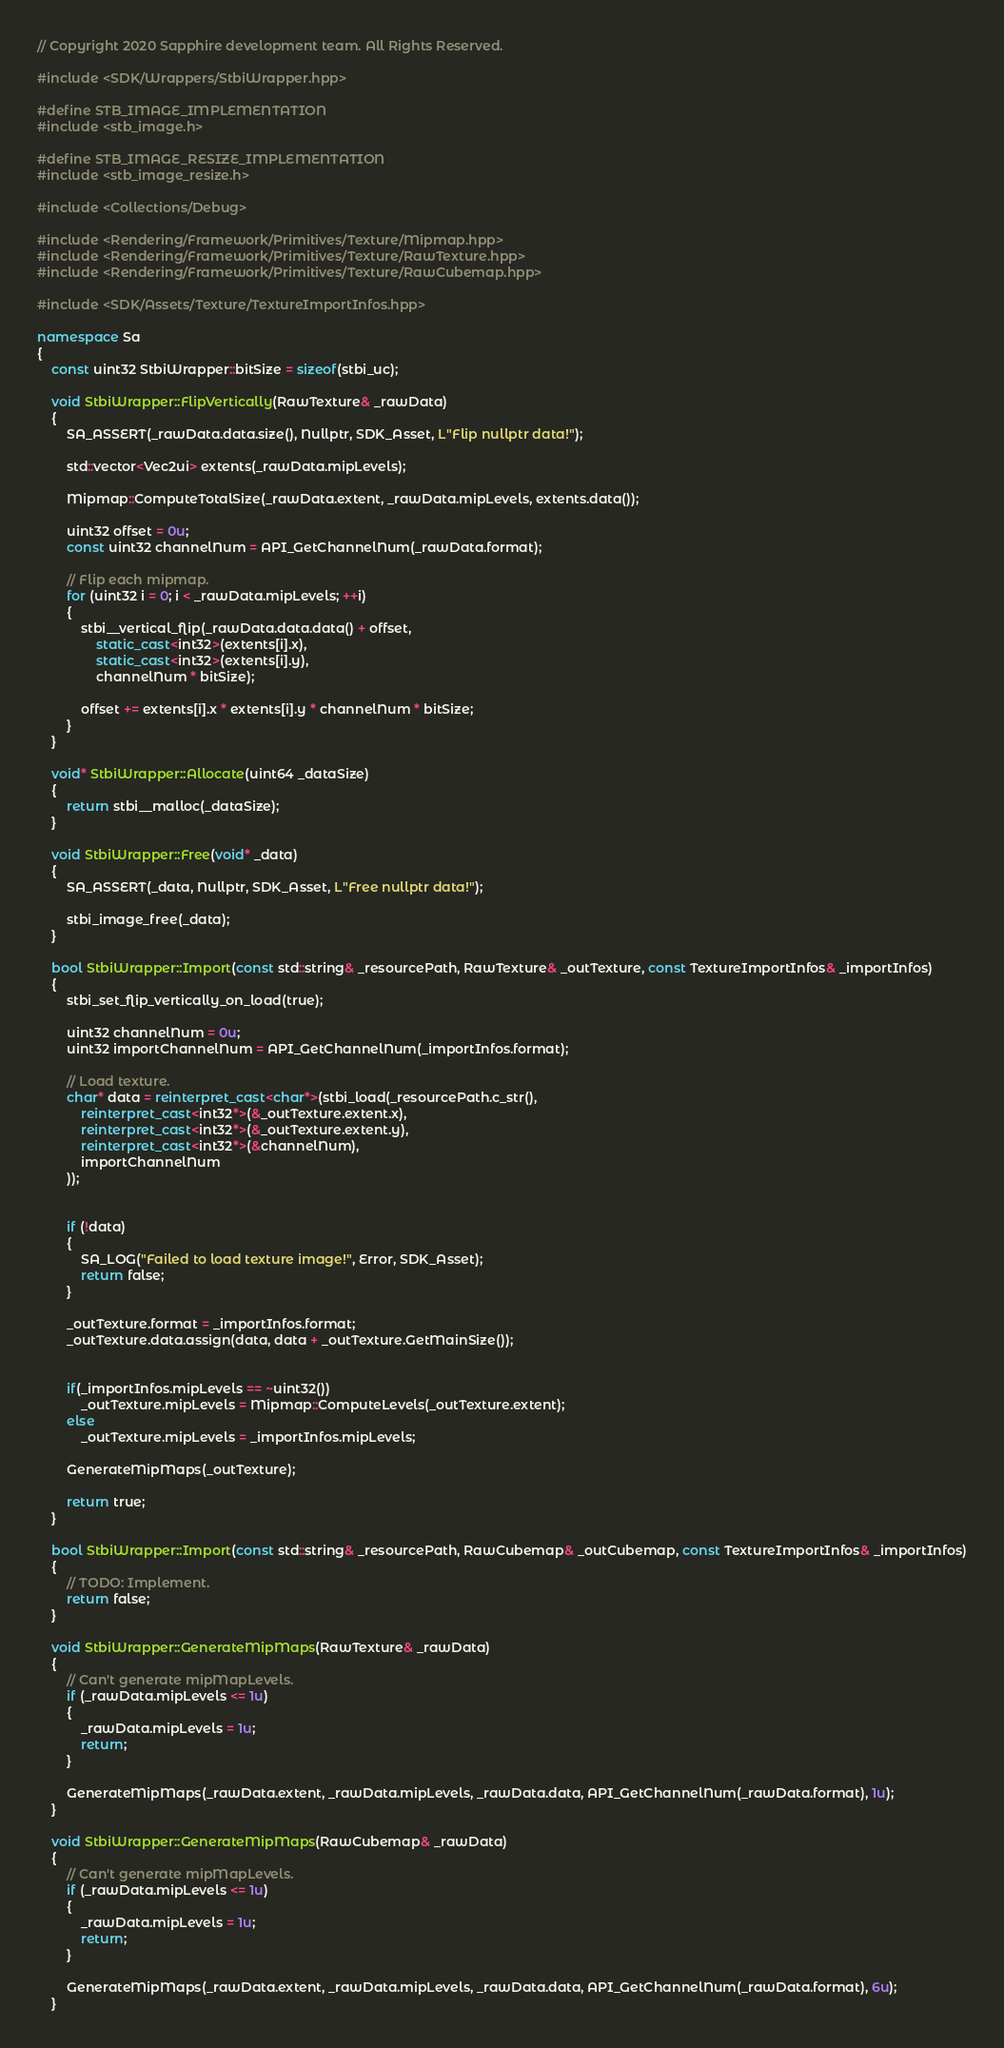<code> <loc_0><loc_0><loc_500><loc_500><_C++_>// Copyright 2020 Sapphire development team. All Rights Reserved.

#include <SDK/Wrappers/StbiWrapper.hpp>

#define STB_IMAGE_IMPLEMENTATION
#include <stb_image.h>

#define STB_IMAGE_RESIZE_IMPLEMENTATION
#include <stb_image_resize.h>

#include <Collections/Debug>

#include <Rendering/Framework/Primitives/Texture/Mipmap.hpp>
#include <Rendering/Framework/Primitives/Texture/RawTexture.hpp>
#include <Rendering/Framework/Primitives/Texture/RawCubemap.hpp>

#include <SDK/Assets/Texture/TextureImportInfos.hpp>

namespace Sa
{
	const uint32 StbiWrapper::bitSize = sizeof(stbi_uc);
	
	void StbiWrapper::FlipVertically(RawTexture& _rawData)
	{
		SA_ASSERT(_rawData.data.size(), Nullptr, SDK_Asset, L"Flip nullptr data!");

		std::vector<Vec2ui> extents(_rawData.mipLevels);

		Mipmap::ComputeTotalSize(_rawData.extent, _rawData.mipLevels, extents.data());

		uint32 offset = 0u;
		const uint32 channelNum = API_GetChannelNum(_rawData.format);

		// Flip each mipmap.
		for (uint32 i = 0; i < _rawData.mipLevels; ++i)
		{
			stbi__vertical_flip(_rawData.data.data() + offset,
				static_cast<int32>(extents[i].x),
				static_cast<int32>(extents[i].y),
				channelNum * bitSize);

			offset += extents[i].x * extents[i].y * channelNum * bitSize;
		}
	}

	void* StbiWrapper::Allocate(uint64 _dataSize)
	{
		return stbi__malloc(_dataSize);
	}
	
	void StbiWrapper::Free(void* _data)
	{
		SA_ASSERT(_data, Nullptr, SDK_Asset, L"Free nullptr data!");

		stbi_image_free(_data);
	}

	bool StbiWrapper::Import(const std::string& _resourcePath, RawTexture& _outTexture, const TextureImportInfos& _importInfos)
	{
		stbi_set_flip_vertically_on_load(true);

		uint32 channelNum = 0u;
		uint32 importChannelNum = API_GetChannelNum(_importInfos.format);

		// Load texture.
		char* data = reinterpret_cast<char*>(stbi_load(_resourcePath.c_str(),
			reinterpret_cast<int32*>(&_outTexture.extent.x),
			reinterpret_cast<int32*>(&_outTexture.extent.y),
			reinterpret_cast<int32*>(&channelNum),
			importChannelNum
		));


		if (!data)
		{
			SA_LOG("Failed to load texture image!", Error, SDK_Asset);
			return false;
		}

		_outTexture.format = _importInfos.format;
		_outTexture.data.assign(data, data + _outTexture.GetMainSize());


		if(_importInfos.mipLevels == ~uint32())
			_outTexture.mipLevels = Mipmap::ComputeLevels(_outTexture.extent);
		else
			_outTexture.mipLevels = _importInfos.mipLevels;

		GenerateMipMaps(_outTexture);

		return true;
	}

	bool StbiWrapper::Import(const std::string& _resourcePath, RawCubemap& _outCubemap, const TextureImportInfos& _importInfos)
	{
		// TODO: Implement.
		return false;
	}

	void StbiWrapper::GenerateMipMaps(RawTexture& _rawData)
	{
		// Can't generate mipMapLevels.
		if (_rawData.mipLevels <= 1u)
		{
			_rawData.mipLevels = 1u;
			return;
		}

		GenerateMipMaps(_rawData.extent, _rawData.mipLevels, _rawData.data, API_GetChannelNum(_rawData.format), 1u);
	}

	void StbiWrapper::GenerateMipMaps(RawCubemap& _rawData)
	{
		// Can't generate mipMapLevels.
		if (_rawData.mipLevels <= 1u)
		{
			_rawData.mipLevels = 1u;
			return;
		}

		GenerateMipMaps(_rawData.extent, _rawData.mipLevels, _rawData.data, API_GetChannelNum(_rawData.format), 6u);
	}
</code> 